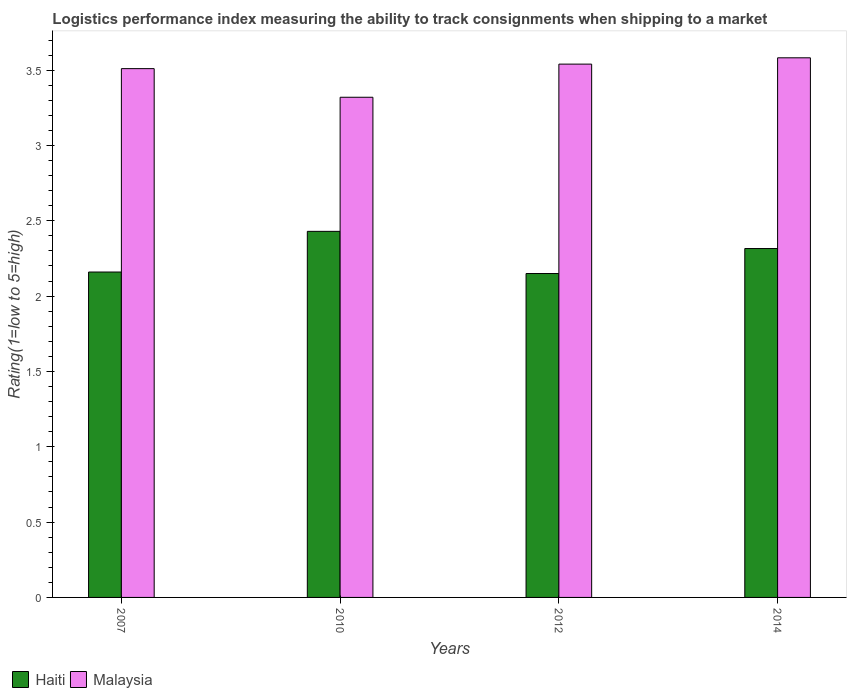How many groups of bars are there?
Give a very brief answer. 4. How many bars are there on the 1st tick from the right?
Keep it short and to the point. 2. What is the Logistic performance index in Haiti in 2012?
Your answer should be very brief. 2.15. Across all years, what is the maximum Logistic performance index in Haiti?
Offer a terse response. 2.43. Across all years, what is the minimum Logistic performance index in Haiti?
Offer a very short reply. 2.15. What is the total Logistic performance index in Malaysia in the graph?
Provide a succinct answer. 13.95. What is the difference between the Logistic performance index in Malaysia in 2012 and that in 2014?
Your answer should be very brief. -0.04. What is the difference between the Logistic performance index in Malaysia in 2007 and the Logistic performance index in Haiti in 2010?
Offer a terse response. 1.08. What is the average Logistic performance index in Malaysia per year?
Make the answer very short. 3.49. In the year 2012, what is the difference between the Logistic performance index in Haiti and Logistic performance index in Malaysia?
Ensure brevity in your answer.  -1.39. What is the ratio of the Logistic performance index in Malaysia in 2010 to that in 2012?
Keep it short and to the point. 0.94. Is the difference between the Logistic performance index in Haiti in 2007 and 2010 greater than the difference between the Logistic performance index in Malaysia in 2007 and 2010?
Your answer should be very brief. No. What is the difference between the highest and the second highest Logistic performance index in Malaysia?
Keep it short and to the point. 0.04. What is the difference between the highest and the lowest Logistic performance index in Haiti?
Keep it short and to the point. 0.28. What does the 2nd bar from the left in 2010 represents?
Your answer should be compact. Malaysia. What does the 2nd bar from the right in 2007 represents?
Your response must be concise. Haiti. How many bars are there?
Give a very brief answer. 8. How many years are there in the graph?
Ensure brevity in your answer.  4. What is the difference between two consecutive major ticks on the Y-axis?
Your answer should be very brief. 0.5. Does the graph contain any zero values?
Your answer should be compact. No. What is the title of the graph?
Give a very brief answer. Logistics performance index measuring the ability to track consignments when shipping to a market. What is the label or title of the X-axis?
Offer a terse response. Years. What is the label or title of the Y-axis?
Offer a terse response. Rating(1=low to 5=high). What is the Rating(1=low to 5=high) of Haiti in 2007?
Give a very brief answer. 2.16. What is the Rating(1=low to 5=high) of Malaysia in 2007?
Your response must be concise. 3.51. What is the Rating(1=low to 5=high) of Haiti in 2010?
Your answer should be very brief. 2.43. What is the Rating(1=low to 5=high) of Malaysia in 2010?
Your answer should be very brief. 3.32. What is the Rating(1=low to 5=high) of Haiti in 2012?
Offer a terse response. 2.15. What is the Rating(1=low to 5=high) of Malaysia in 2012?
Give a very brief answer. 3.54. What is the Rating(1=low to 5=high) of Haiti in 2014?
Offer a terse response. 2.32. What is the Rating(1=low to 5=high) of Malaysia in 2014?
Keep it short and to the point. 3.58. Across all years, what is the maximum Rating(1=low to 5=high) of Haiti?
Keep it short and to the point. 2.43. Across all years, what is the maximum Rating(1=low to 5=high) of Malaysia?
Offer a terse response. 3.58. Across all years, what is the minimum Rating(1=low to 5=high) in Haiti?
Provide a succinct answer. 2.15. Across all years, what is the minimum Rating(1=low to 5=high) in Malaysia?
Provide a short and direct response. 3.32. What is the total Rating(1=low to 5=high) of Haiti in the graph?
Offer a very short reply. 9.06. What is the total Rating(1=low to 5=high) of Malaysia in the graph?
Your response must be concise. 13.95. What is the difference between the Rating(1=low to 5=high) in Haiti in 2007 and that in 2010?
Your answer should be compact. -0.27. What is the difference between the Rating(1=low to 5=high) of Malaysia in 2007 and that in 2010?
Your answer should be very brief. 0.19. What is the difference between the Rating(1=low to 5=high) in Malaysia in 2007 and that in 2012?
Provide a succinct answer. -0.03. What is the difference between the Rating(1=low to 5=high) in Haiti in 2007 and that in 2014?
Make the answer very short. -0.16. What is the difference between the Rating(1=low to 5=high) of Malaysia in 2007 and that in 2014?
Provide a short and direct response. -0.07. What is the difference between the Rating(1=low to 5=high) in Haiti in 2010 and that in 2012?
Make the answer very short. 0.28. What is the difference between the Rating(1=low to 5=high) in Malaysia in 2010 and that in 2012?
Provide a short and direct response. -0.22. What is the difference between the Rating(1=low to 5=high) of Haiti in 2010 and that in 2014?
Provide a succinct answer. 0.11. What is the difference between the Rating(1=low to 5=high) in Malaysia in 2010 and that in 2014?
Ensure brevity in your answer.  -0.26. What is the difference between the Rating(1=low to 5=high) of Haiti in 2012 and that in 2014?
Your response must be concise. -0.17. What is the difference between the Rating(1=low to 5=high) in Malaysia in 2012 and that in 2014?
Your answer should be compact. -0.04. What is the difference between the Rating(1=low to 5=high) of Haiti in 2007 and the Rating(1=low to 5=high) of Malaysia in 2010?
Offer a terse response. -1.16. What is the difference between the Rating(1=low to 5=high) of Haiti in 2007 and the Rating(1=low to 5=high) of Malaysia in 2012?
Provide a succinct answer. -1.38. What is the difference between the Rating(1=low to 5=high) in Haiti in 2007 and the Rating(1=low to 5=high) in Malaysia in 2014?
Provide a succinct answer. -1.42. What is the difference between the Rating(1=low to 5=high) in Haiti in 2010 and the Rating(1=low to 5=high) in Malaysia in 2012?
Ensure brevity in your answer.  -1.11. What is the difference between the Rating(1=low to 5=high) in Haiti in 2010 and the Rating(1=low to 5=high) in Malaysia in 2014?
Provide a short and direct response. -1.15. What is the difference between the Rating(1=low to 5=high) of Haiti in 2012 and the Rating(1=low to 5=high) of Malaysia in 2014?
Provide a short and direct response. -1.43. What is the average Rating(1=low to 5=high) in Haiti per year?
Ensure brevity in your answer.  2.26. What is the average Rating(1=low to 5=high) of Malaysia per year?
Offer a very short reply. 3.49. In the year 2007, what is the difference between the Rating(1=low to 5=high) of Haiti and Rating(1=low to 5=high) of Malaysia?
Your answer should be compact. -1.35. In the year 2010, what is the difference between the Rating(1=low to 5=high) in Haiti and Rating(1=low to 5=high) in Malaysia?
Give a very brief answer. -0.89. In the year 2012, what is the difference between the Rating(1=low to 5=high) in Haiti and Rating(1=low to 5=high) in Malaysia?
Keep it short and to the point. -1.39. In the year 2014, what is the difference between the Rating(1=low to 5=high) of Haiti and Rating(1=low to 5=high) of Malaysia?
Your answer should be compact. -1.27. What is the ratio of the Rating(1=low to 5=high) in Malaysia in 2007 to that in 2010?
Ensure brevity in your answer.  1.06. What is the ratio of the Rating(1=low to 5=high) in Haiti in 2007 to that in 2014?
Provide a succinct answer. 0.93. What is the ratio of the Rating(1=low to 5=high) of Malaysia in 2007 to that in 2014?
Keep it short and to the point. 0.98. What is the ratio of the Rating(1=low to 5=high) in Haiti in 2010 to that in 2012?
Your response must be concise. 1.13. What is the ratio of the Rating(1=low to 5=high) of Malaysia in 2010 to that in 2012?
Offer a very short reply. 0.94. What is the ratio of the Rating(1=low to 5=high) of Haiti in 2010 to that in 2014?
Provide a succinct answer. 1.05. What is the ratio of the Rating(1=low to 5=high) in Malaysia in 2010 to that in 2014?
Give a very brief answer. 0.93. What is the ratio of the Rating(1=low to 5=high) of Haiti in 2012 to that in 2014?
Make the answer very short. 0.93. What is the ratio of the Rating(1=low to 5=high) in Malaysia in 2012 to that in 2014?
Offer a very short reply. 0.99. What is the difference between the highest and the second highest Rating(1=low to 5=high) in Haiti?
Your answer should be compact. 0.11. What is the difference between the highest and the second highest Rating(1=low to 5=high) of Malaysia?
Your response must be concise. 0.04. What is the difference between the highest and the lowest Rating(1=low to 5=high) in Haiti?
Provide a short and direct response. 0.28. What is the difference between the highest and the lowest Rating(1=low to 5=high) of Malaysia?
Make the answer very short. 0.26. 